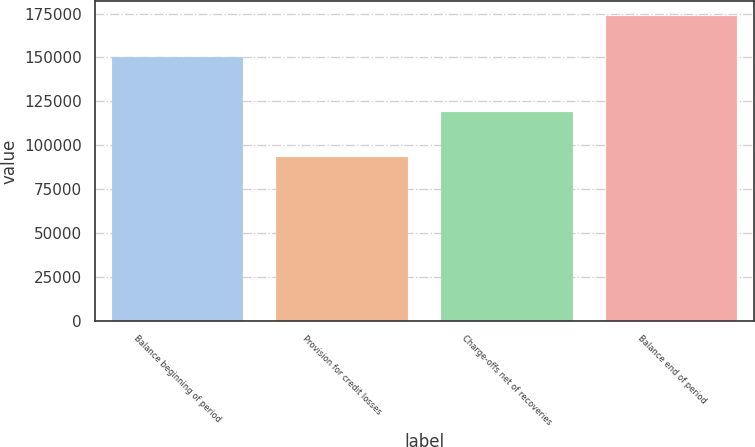Convert chart to OTSL. <chart><loc_0><loc_0><loc_500><loc_500><bar_chart><fcel>Balance beginning of period<fcel>Provision for credit losses<fcel>Charge-offs net of recoveries<fcel>Balance end of period<nl><fcel>150082<fcel>93118<fcel>119035<fcel>173589<nl></chart> 